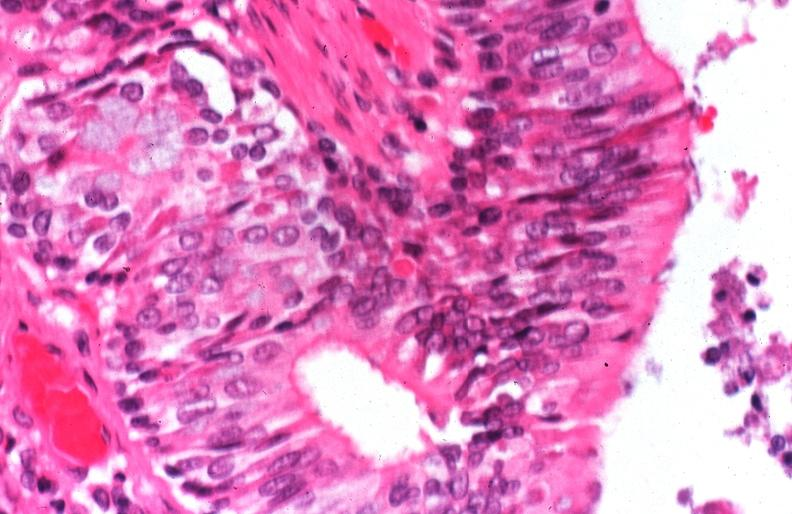does this image show lung, cystic fibrosis?
Answer the question using a single word or phrase. Yes 